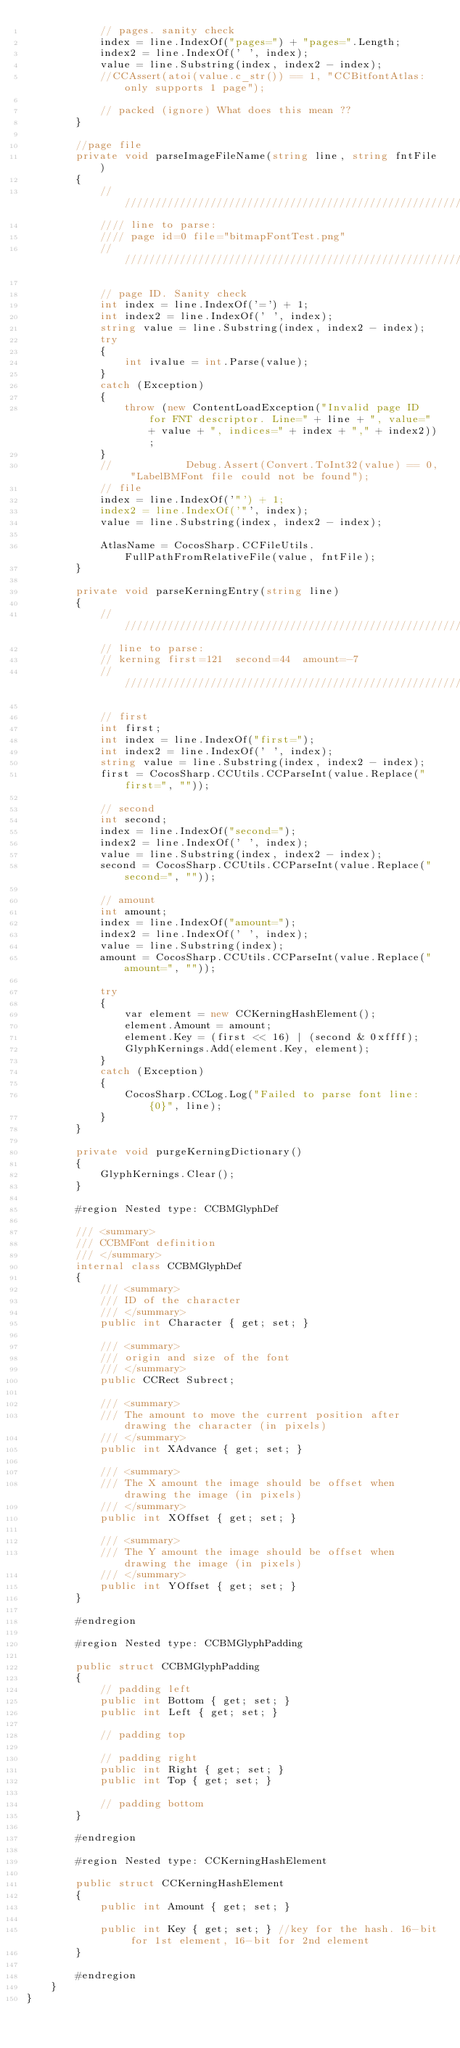Convert code to text. <code><loc_0><loc_0><loc_500><loc_500><_C#_>            // pages. sanity check
            index = line.IndexOf("pages=") + "pages=".Length;
            index2 = line.IndexOf(' ', index);
            value = line.Substring(index, index2 - index);
            //CCAssert(atoi(value.c_str()) == 1, "CCBitfontAtlas: only supports 1 page");

            // packed (ignore) What does this mean ??
        }

        //page file
        private void parseImageFileName(string line, string fntFile)
        {
            //    //////////////////////////////////////////////////////////////////////////
            //// line to parse:
            //// page id=0 file="bitmapFontTest.png"
            ////////////////////////////////////////////////////////////////////////////

            // page ID. Sanity check
            int index = line.IndexOf('=') + 1;
            int index2 = line.IndexOf(' ', index);
            string value = line.Substring(index, index2 - index);
            try
            {
                int ivalue = int.Parse(value);
            }
            catch (Exception)
            {
                throw (new ContentLoadException("Invalid page ID for FNT descriptor. Line=" + line + ", value=" + value + ", indices=" + index + "," + index2));
            }
            //            Debug.Assert(Convert.ToInt32(value) == 0, "LabelBMFont file could not be found");
            // file 
            index = line.IndexOf('"') + 1;
            index2 = line.IndexOf('"', index);
            value = line.Substring(index, index2 - index);

            AtlasName = CocosSharp.CCFileUtils.FullPathFromRelativeFile(value, fntFile);
        }

        private void parseKerningEntry(string line)
        {
            //////////////////////////////////////////////////////////////////////////
            // line to parse:
            // kerning first=121  second=44  amount=-7
            //////////////////////////////////////////////////////////////////////////

            // first
            int first;
            int index = line.IndexOf("first=");
            int index2 = line.IndexOf(' ', index);
            string value = line.Substring(index, index2 - index);
            first = CocosSharp.CCUtils.CCParseInt(value.Replace("first=", ""));

            // second
            int second;
            index = line.IndexOf("second=");
            index2 = line.IndexOf(' ', index);
            value = line.Substring(index, index2 - index);
            second = CocosSharp.CCUtils.CCParseInt(value.Replace("second=", ""));

            // amount
            int amount;
            index = line.IndexOf("amount=");
            index2 = line.IndexOf(' ', index);
            value = line.Substring(index);
            amount = CocosSharp.CCUtils.CCParseInt(value.Replace("amount=", ""));

            try
            {
                var element = new CCKerningHashElement();
                element.Amount = amount;
                element.Key = (first << 16) | (second & 0xffff);
                GlyphKernings.Add(element.Key, element);
            }
            catch (Exception)
            {
                CocosSharp.CCLog.Log("Failed to parse font line: {0}", line);
            }
        }

        private void purgeKerningDictionary()
        {
            GlyphKernings.Clear();
        }

        #region Nested type: CCBMGlyphDef

        /// <summary>
        /// CCBMFont definition
        /// </summary>
        internal class CCBMGlyphDef
        {
            /// <summary>
            /// ID of the character
            /// </summary>
            public int Character { get; set; }

            /// <summary>
            /// origin and size of the font
            /// </summary>
            public CCRect Subrect;

            /// <summary>
            /// The amount to move the current position after drawing the character (in pixels)
            /// </summary>
            public int XAdvance { get; set; }

            /// <summary>
            /// The X amount the image should be offset when drawing the image (in pixels)
            /// </summary>
            public int XOffset { get; set; }

            /// <summary>
            /// The Y amount the image should be offset when drawing the image (in pixels)
            /// </summary>
            public int YOffset { get; set; }
        }

        #endregion

        #region Nested type: CCBMGlyphPadding

        public struct CCBMGlyphPadding
        {
            // padding left
            public int Bottom { get; set; }
            public int Left { get; set; }

            // padding top

            // padding right
            public int Right { get; set; }
            public int Top { get; set; }

            // padding bottom
        }

        #endregion

        #region Nested type: CCKerningHashElement

        public struct CCKerningHashElement
        {
            public int Amount { get; set; }

            public int Key { get; set; } //key for the hash. 16-bit for 1st element, 16-bit for 2nd element
        }

        #endregion
    }
}</code> 